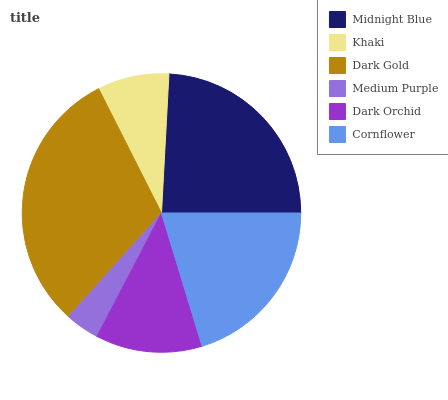Is Medium Purple the minimum?
Answer yes or no. Yes. Is Dark Gold the maximum?
Answer yes or no. Yes. Is Khaki the minimum?
Answer yes or no. No. Is Khaki the maximum?
Answer yes or no. No. Is Midnight Blue greater than Khaki?
Answer yes or no. Yes. Is Khaki less than Midnight Blue?
Answer yes or no. Yes. Is Khaki greater than Midnight Blue?
Answer yes or no. No. Is Midnight Blue less than Khaki?
Answer yes or no. No. Is Cornflower the high median?
Answer yes or no. Yes. Is Dark Orchid the low median?
Answer yes or no. Yes. Is Dark Orchid the high median?
Answer yes or no. No. Is Cornflower the low median?
Answer yes or no. No. 